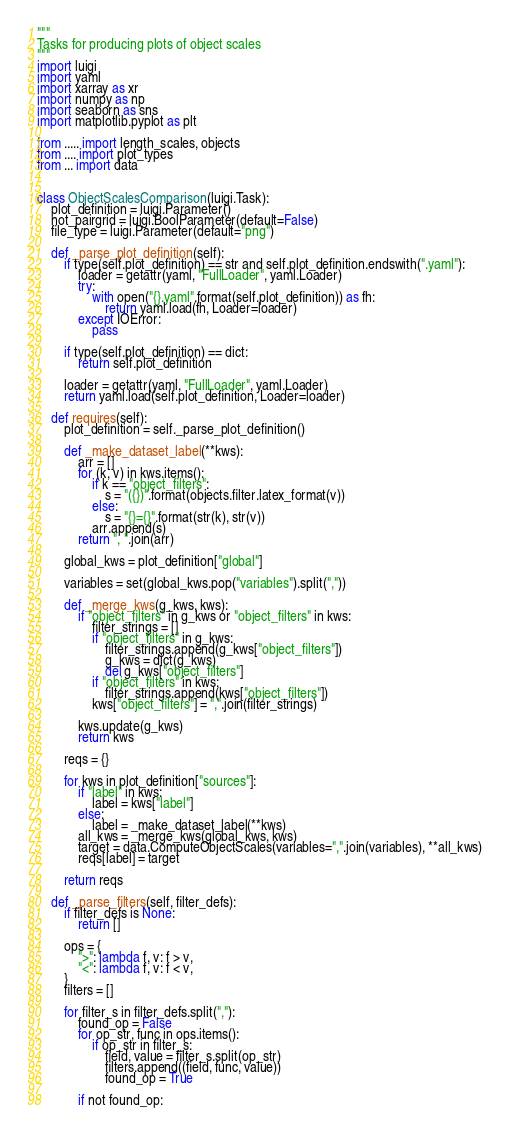<code> <loc_0><loc_0><loc_500><loc_500><_Python_>"""
Tasks for producing plots of object scales
"""
import luigi
import yaml
import xarray as xr
import numpy as np
import seaborn as sns
import matplotlib.pyplot as plt

from ..... import length_scales, objects
from .... import plot_types
from ... import data


class ObjectScalesComparison(luigi.Task):
    plot_definition = luigi.Parameter()
    not_pairgrid = luigi.BoolParameter(default=False)
    file_type = luigi.Parameter(default="png")

    def _parse_plot_definition(self):
        if type(self.plot_definition) == str and self.plot_definition.endswith(".yaml"):
            loader = getattr(yaml, "FullLoader", yaml.Loader)
            try:
                with open("{}.yaml".format(self.plot_definition)) as fh:
                    return yaml.load(fh, Loader=loader)
            except IOError:
                pass

        if type(self.plot_definition) == dict:
            return self.plot_definition

        loader = getattr(yaml, "FullLoader", yaml.Loader)
        return yaml.load(self.plot_definition, Loader=loader)

    def requires(self):
        plot_definition = self._parse_plot_definition()

        def _make_dataset_label(**kws):
            arr = []
            for (k, v) in kws.items():
                if k == "object_filters":
                    s = "({})".format(objects.filter.latex_format(v))
                else:
                    s = "{}={}".format(str(k), str(v))
                arr.append(s)
            return ", ".join(arr)

        global_kws = plot_definition["global"]

        variables = set(global_kws.pop("variables").split(","))

        def _merge_kws(g_kws, kws):
            if "object_filters" in g_kws or "object_filters" in kws:
                filter_strings = []
                if "object_filters" in g_kws:
                    filter_strings.append(g_kws["object_filters"])
                    g_kws = dict(g_kws)
                    del g_kws["object_filters"]
                if "object_filters" in kws:
                    filter_strings.append(kws["object_filters"])
                kws["object_filters"] = ",".join(filter_strings)

            kws.update(g_kws)
            return kws

        reqs = {}

        for kws in plot_definition["sources"]:
            if "label" in kws:
                label = kws["label"]
            else:
                label = _make_dataset_label(**kws)
            all_kws = _merge_kws(global_kws, kws)
            target = data.ComputeObjectScales(variables=",".join(variables), **all_kws)
            reqs[label] = target

        return reqs

    def _parse_filters(self, filter_defs):
        if filter_defs is None:
            return []

        ops = {
            ">": lambda f, v: f > v,
            "<": lambda f, v: f < v,
        }
        filters = []

        for filter_s in filter_defs.split(","):
            found_op = False
            for op_str, func in ops.items():
                if op_str in filter_s:
                    field, value = filter_s.split(op_str)
                    filters.append((field, func, value))
                    found_op = True

            if not found_op:</code> 